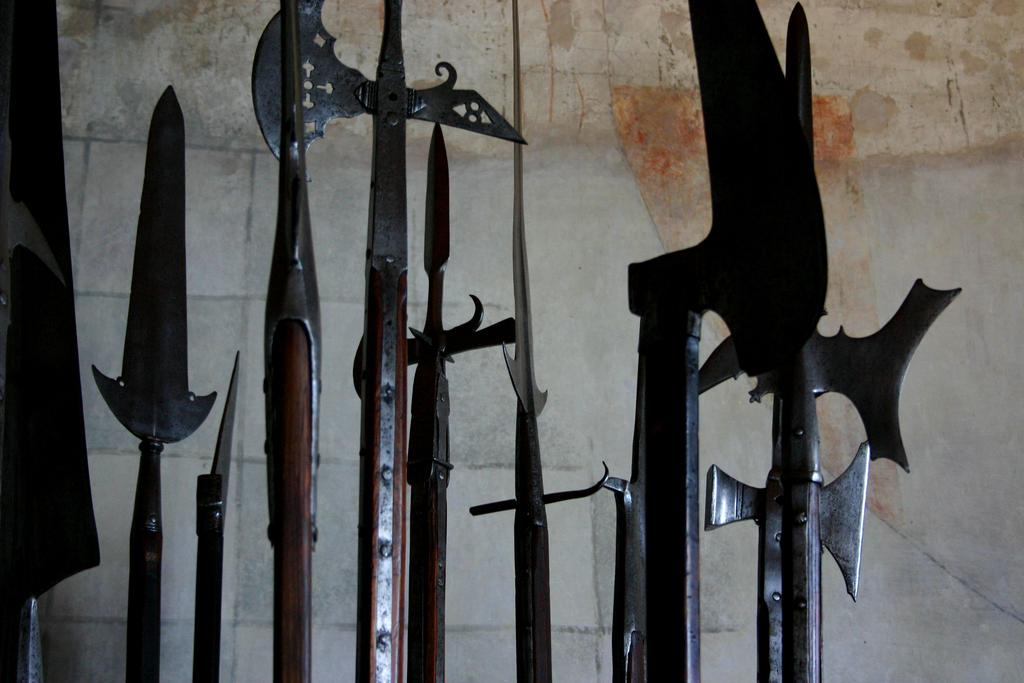What objects in the image are related to combat or defense? There are weapons in the image. What type of structure can be seen in the background of the image? There is a stone wall in the background of the image. What type of coil is being used by the friends in the image? There are no friends or coils present in the image; it features weapons and a stone wall. What type of brush is visible in the image? There is no brush present in the image. 